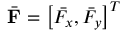<formula> <loc_0><loc_0><loc_500><loc_500>\bar { F } = \left [ \bar { F _ { x } } , \bar { F _ { y } } \right ] ^ { T }</formula> 